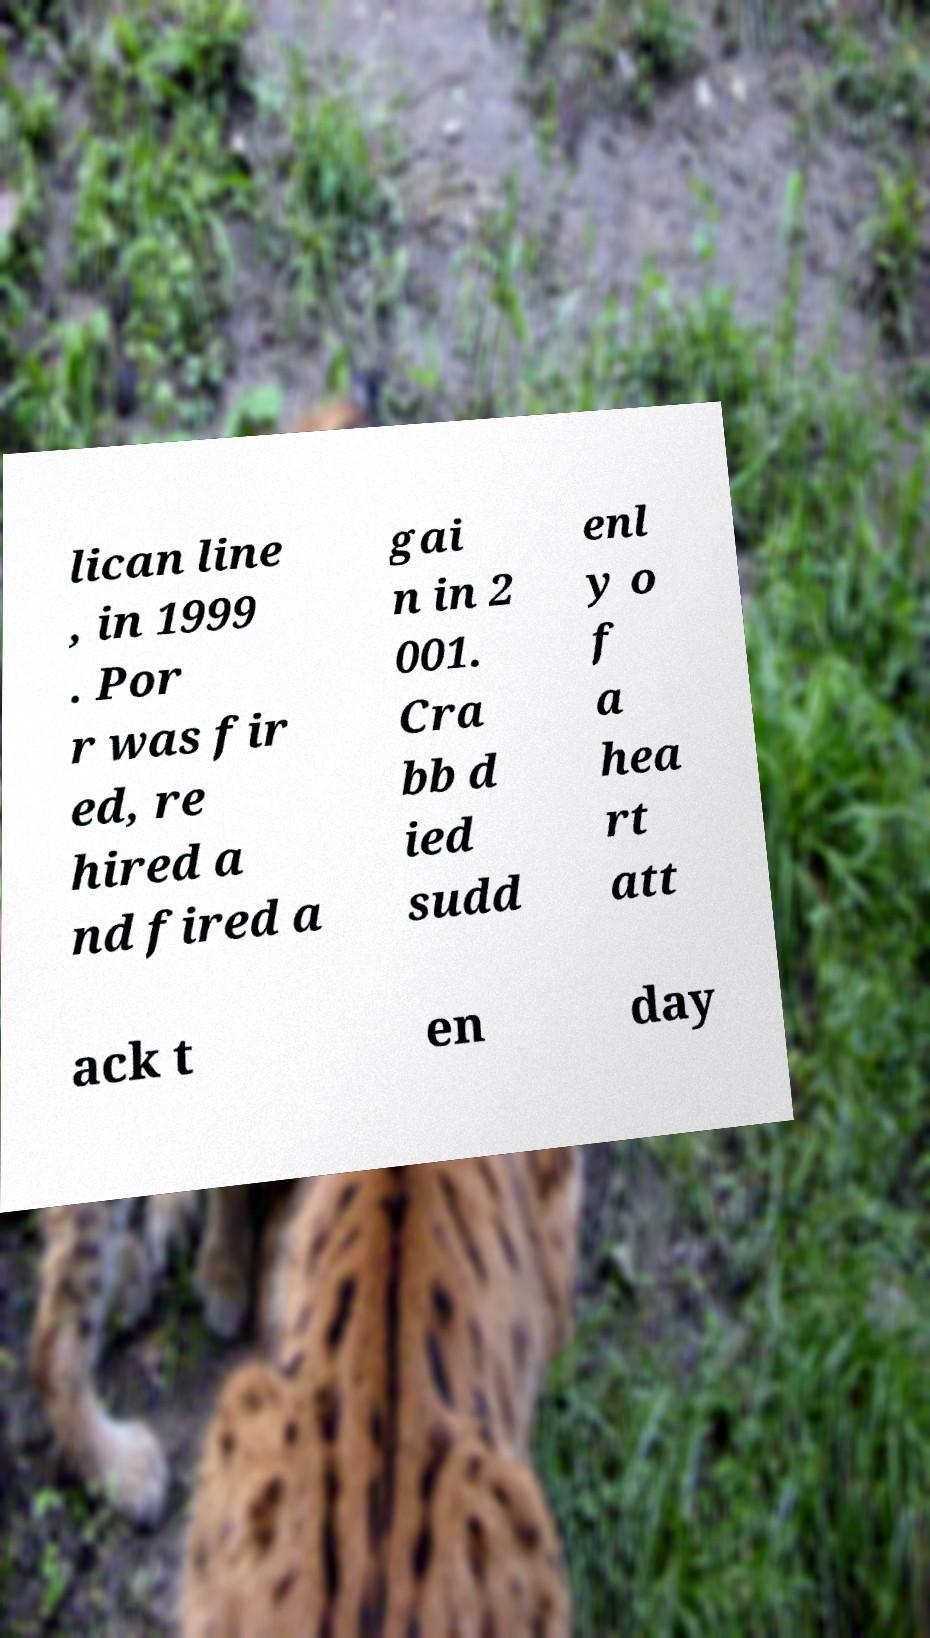Can you accurately transcribe the text from the provided image for me? lican line , in 1999 . Por r was fir ed, re hired a nd fired a gai n in 2 001. Cra bb d ied sudd enl y o f a hea rt att ack t en day 